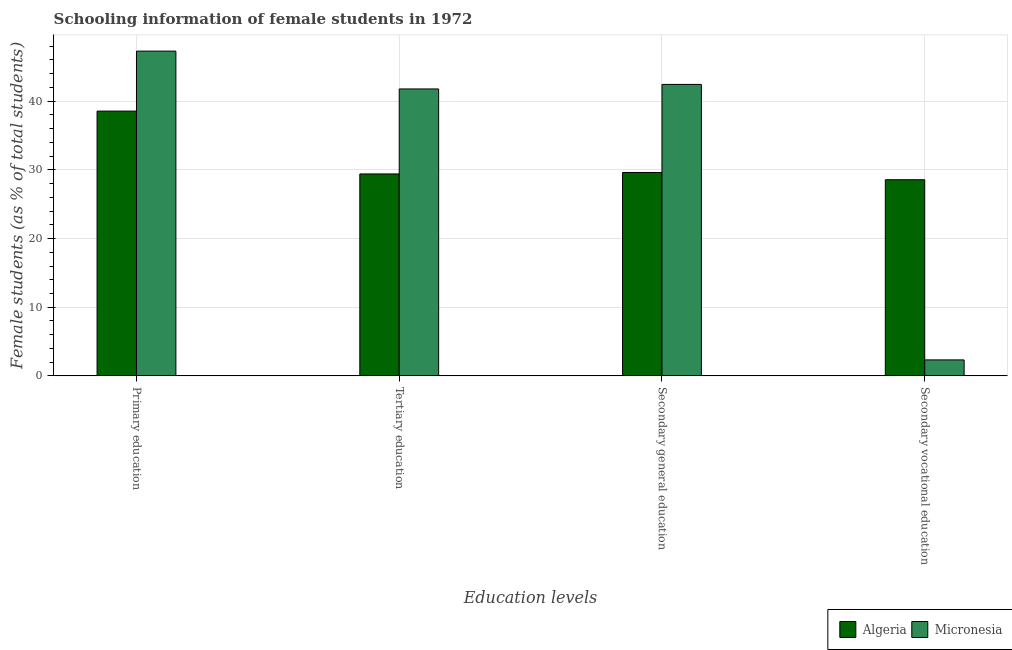How many different coloured bars are there?
Offer a terse response. 2. How many groups of bars are there?
Provide a succinct answer. 4. Are the number of bars per tick equal to the number of legend labels?
Offer a very short reply. Yes. How many bars are there on the 3rd tick from the right?
Your answer should be very brief. 2. What is the label of the 3rd group of bars from the left?
Provide a short and direct response. Secondary general education. What is the percentage of female students in secondary education in Micronesia?
Your answer should be very brief. 42.44. Across all countries, what is the maximum percentage of female students in tertiary education?
Provide a succinct answer. 41.78. Across all countries, what is the minimum percentage of female students in primary education?
Provide a succinct answer. 38.56. In which country was the percentage of female students in tertiary education maximum?
Your answer should be very brief. Micronesia. In which country was the percentage of female students in primary education minimum?
Your response must be concise. Algeria. What is the total percentage of female students in secondary vocational education in the graph?
Offer a terse response. 30.89. What is the difference between the percentage of female students in tertiary education in Algeria and that in Micronesia?
Provide a succinct answer. -12.38. What is the difference between the percentage of female students in primary education in Algeria and the percentage of female students in secondary education in Micronesia?
Keep it short and to the point. -3.89. What is the average percentage of female students in secondary education per country?
Give a very brief answer. 36.03. What is the difference between the percentage of female students in secondary vocational education and percentage of female students in primary education in Micronesia?
Your response must be concise. -44.97. What is the ratio of the percentage of female students in primary education in Algeria to that in Micronesia?
Provide a succinct answer. 0.82. Is the percentage of female students in primary education in Micronesia less than that in Algeria?
Ensure brevity in your answer.  No. Is the difference between the percentage of female students in primary education in Micronesia and Algeria greater than the difference between the percentage of female students in tertiary education in Micronesia and Algeria?
Provide a short and direct response. No. What is the difference between the highest and the second highest percentage of female students in secondary vocational education?
Provide a succinct answer. 26.24. What is the difference between the highest and the lowest percentage of female students in secondary education?
Keep it short and to the point. 12.82. In how many countries, is the percentage of female students in primary education greater than the average percentage of female students in primary education taken over all countries?
Your response must be concise. 1. Is it the case that in every country, the sum of the percentage of female students in primary education and percentage of female students in secondary education is greater than the sum of percentage of female students in tertiary education and percentage of female students in secondary vocational education?
Your answer should be very brief. No. What does the 1st bar from the left in Secondary vocational education represents?
Give a very brief answer. Algeria. What does the 2nd bar from the right in Tertiary education represents?
Offer a terse response. Algeria. How many countries are there in the graph?
Offer a very short reply. 2. Are the values on the major ticks of Y-axis written in scientific E-notation?
Offer a very short reply. No. Where does the legend appear in the graph?
Offer a terse response. Bottom right. How many legend labels are there?
Provide a short and direct response. 2. What is the title of the graph?
Make the answer very short. Schooling information of female students in 1972. Does "Iceland" appear as one of the legend labels in the graph?
Make the answer very short. No. What is the label or title of the X-axis?
Offer a very short reply. Education levels. What is the label or title of the Y-axis?
Keep it short and to the point. Female students (as % of total students). What is the Female students (as % of total students) in Algeria in Primary education?
Your answer should be very brief. 38.56. What is the Female students (as % of total students) in Micronesia in Primary education?
Provide a succinct answer. 47.29. What is the Female students (as % of total students) in Algeria in Tertiary education?
Offer a terse response. 29.41. What is the Female students (as % of total students) of Micronesia in Tertiary education?
Keep it short and to the point. 41.78. What is the Female students (as % of total students) in Algeria in Secondary general education?
Provide a succinct answer. 29.62. What is the Female students (as % of total students) in Micronesia in Secondary general education?
Provide a succinct answer. 42.44. What is the Female students (as % of total students) of Algeria in Secondary vocational education?
Keep it short and to the point. 28.56. What is the Female students (as % of total students) in Micronesia in Secondary vocational education?
Make the answer very short. 2.33. Across all Education levels, what is the maximum Female students (as % of total students) in Algeria?
Keep it short and to the point. 38.56. Across all Education levels, what is the maximum Female students (as % of total students) of Micronesia?
Offer a terse response. 47.29. Across all Education levels, what is the minimum Female students (as % of total students) in Algeria?
Provide a succinct answer. 28.56. Across all Education levels, what is the minimum Female students (as % of total students) in Micronesia?
Provide a succinct answer. 2.33. What is the total Female students (as % of total students) in Algeria in the graph?
Your answer should be compact. 126.15. What is the total Female students (as % of total students) in Micronesia in the graph?
Your response must be concise. 133.85. What is the difference between the Female students (as % of total students) of Algeria in Primary education and that in Tertiary education?
Your answer should be compact. 9.15. What is the difference between the Female students (as % of total students) in Micronesia in Primary education and that in Tertiary education?
Your answer should be very brief. 5.51. What is the difference between the Female students (as % of total students) of Algeria in Primary education and that in Secondary general education?
Provide a short and direct response. 8.94. What is the difference between the Female students (as % of total students) in Micronesia in Primary education and that in Secondary general education?
Offer a very short reply. 4.85. What is the difference between the Female students (as % of total students) of Algeria in Primary education and that in Secondary vocational education?
Provide a short and direct response. 10. What is the difference between the Female students (as % of total students) of Micronesia in Primary education and that in Secondary vocational education?
Your answer should be compact. 44.97. What is the difference between the Female students (as % of total students) in Algeria in Tertiary education and that in Secondary general education?
Make the answer very short. -0.21. What is the difference between the Female students (as % of total students) in Micronesia in Tertiary education and that in Secondary general education?
Ensure brevity in your answer.  -0.66. What is the difference between the Female students (as % of total students) in Algeria in Tertiary education and that in Secondary vocational education?
Your answer should be very brief. 0.84. What is the difference between the Female students (as % of total students) of Micronesia in Tertiary education and that in Secondary vocational education?
Keep it short and to the point. 39.46. What is the difference between the Female students (as % of total students) of Algeria in Secondary general education and that in Secondary vocational education?
Offer a terse response. 1.06. What is the difference between the Female students (as % of total students) in Micronesia in Secondary general education and that in Secondary vocational education?
Your response must be concise. 40.12. What is the difference between the Female students (as % of total students) of Algeria in Primary education and the Female students (as % of total students) of Micronesia in Tertiary education?
Offer a very short reply. -3.23. What is the difference between the Female students (as % of total students) of Algeria in Primary education and the Female students (as % of total students) of Micronesia in Secondary general education?
Make the answer very short. -3.89. What is the difference between the Female students (as % of total students) in Algeria in Primary education and the Female students (as % of total students) in Micronesia in Secondary vocational education?
Offer a very short reply. 36.23. What is the difference between the Female students (as % of total students) in Algeria in Tertiary education and the Female students (as % of total students) in Micronesia in Secondary general education?
Your response must be concise. -13.04. What is the difference between the Female students (as % of total students) of Algeria in Tertiary education and the Female students (as % of total students) of Micronesia in Secondary vocational education?
Provide a succinct answer. 27.08. What is the difference between the Female students (as % of total students) in Algeria in Secondary general education and the Female students (as % of total students) in Micronesia in Secondary vocational education?
Offer a very short reply. 27.29. What is the average Female students (as % of total students) of Algeria per Education levels?
Your answer should be compact. 31.54. What is the average Female students (as % of total students) of Micronesia per Education levels?
Provide a succinct answer. 33.46. What is the difference between the Female students (as % of total students) of Algeria and Female students (as % of total students) of Micronesia in Primary education?
Offer a terse response. -8.74. What is the difference between the Female students (as % of total students) in Algeria and Female students (as % of total students) in Micronesia in Tertiary education?
Your answer should be very brief. -12.38. What is the difference between the Female students (as % of total students) of Algeria and Female students (as % of total students) of Micronesia in Secondary general education?
Your answer should be very brief. -12.82. What is the difference between the Female students (as % of total students) of Algeria and Female students (as % of total students) of Micronesia in Secondary vocational education?
Provide a succinct answer. 26.24. What is the ratio of the Female students (as % of total students) of Algeria in Primary education to that in Tertiary education?
Offer a very short reply. 1.31. What is the ratio of the Female students (as % of total students) of Micronesia in Primary education to that in Tertiary education?
Provide a succinct answer. 1.13. What is the ratio of the Female students (as % of total students) in Algeria in Primary education to that in Secondary general education?
Your answer should be very brief. 1.3. What is the ratio of the Female students (as % of total students) of Micronesia in Primary education to that in Secondary general education?
Your response must be concise. 1.11. What is the ratio of the Female students (as % of total students) in Algeria in Primary education to that in Secondary vocational education?
Offer a terse response. 1.35. What is the ratio of the Female students (as % of total students) in Micronesia in Primary education to that in Secondary vocational education?
Offer a terse response. 20.34. What is the ratio of the Female students (as % of total students) in Micronesia in Tertiary education to that in Secondary general education?
Provide a short and direct response. 0.98. What is the ratio of the Female students (as % of total students) of Algeria in Tertiary education to that in Secondary vocational education?
Provide a short and direct response. 1.03. What is the ratio of the Female students (as % of total students) in Micronesia in Tertiary education to that in Secondary vocational education?
Provide a succinct answer. 17.97. What is the ratio of the Female students (as % of total students) of Micronesia in Secondary general education to that in Secondary vocational education?
Offer a terse response. 18.25. What is the difference between the highest and the second highest Female students (as % of total students) of Algeria?
Give a very brief answer. 8.94. What is the difference between the highest and the second highest Female students (as % of total students) in Micronesia?
Offer a very short reply. 4.85. What is the difference between the highest and the lowest Female students (as % of total students) in Algeria?
Keep it short and to the point. 10. What is the difference between the highest and the lowest Female students (as % of total students) in Micronesia?
Provide a short and direct response. 44.97. 